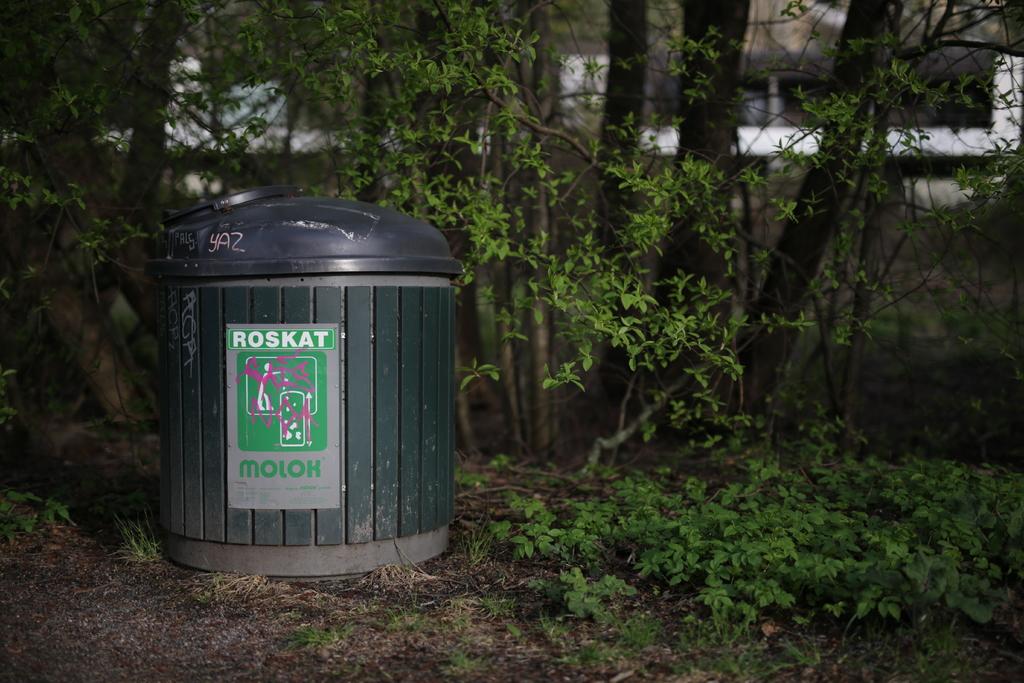What is this made for?
Keep it short and to the point. Roskat. 